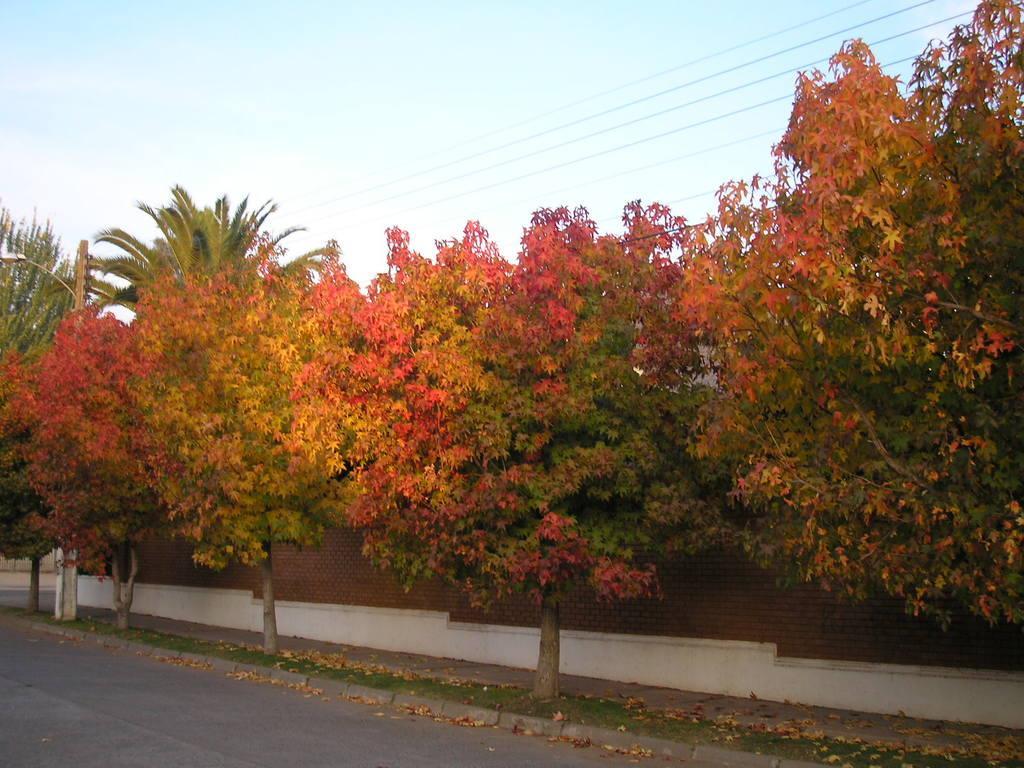In one or two sentences, can you explain what this image depicts? In this image, we can see trees, a light pole and there is a wall. At the top, there are wires and there is sky. At the bottom, there is a road. 